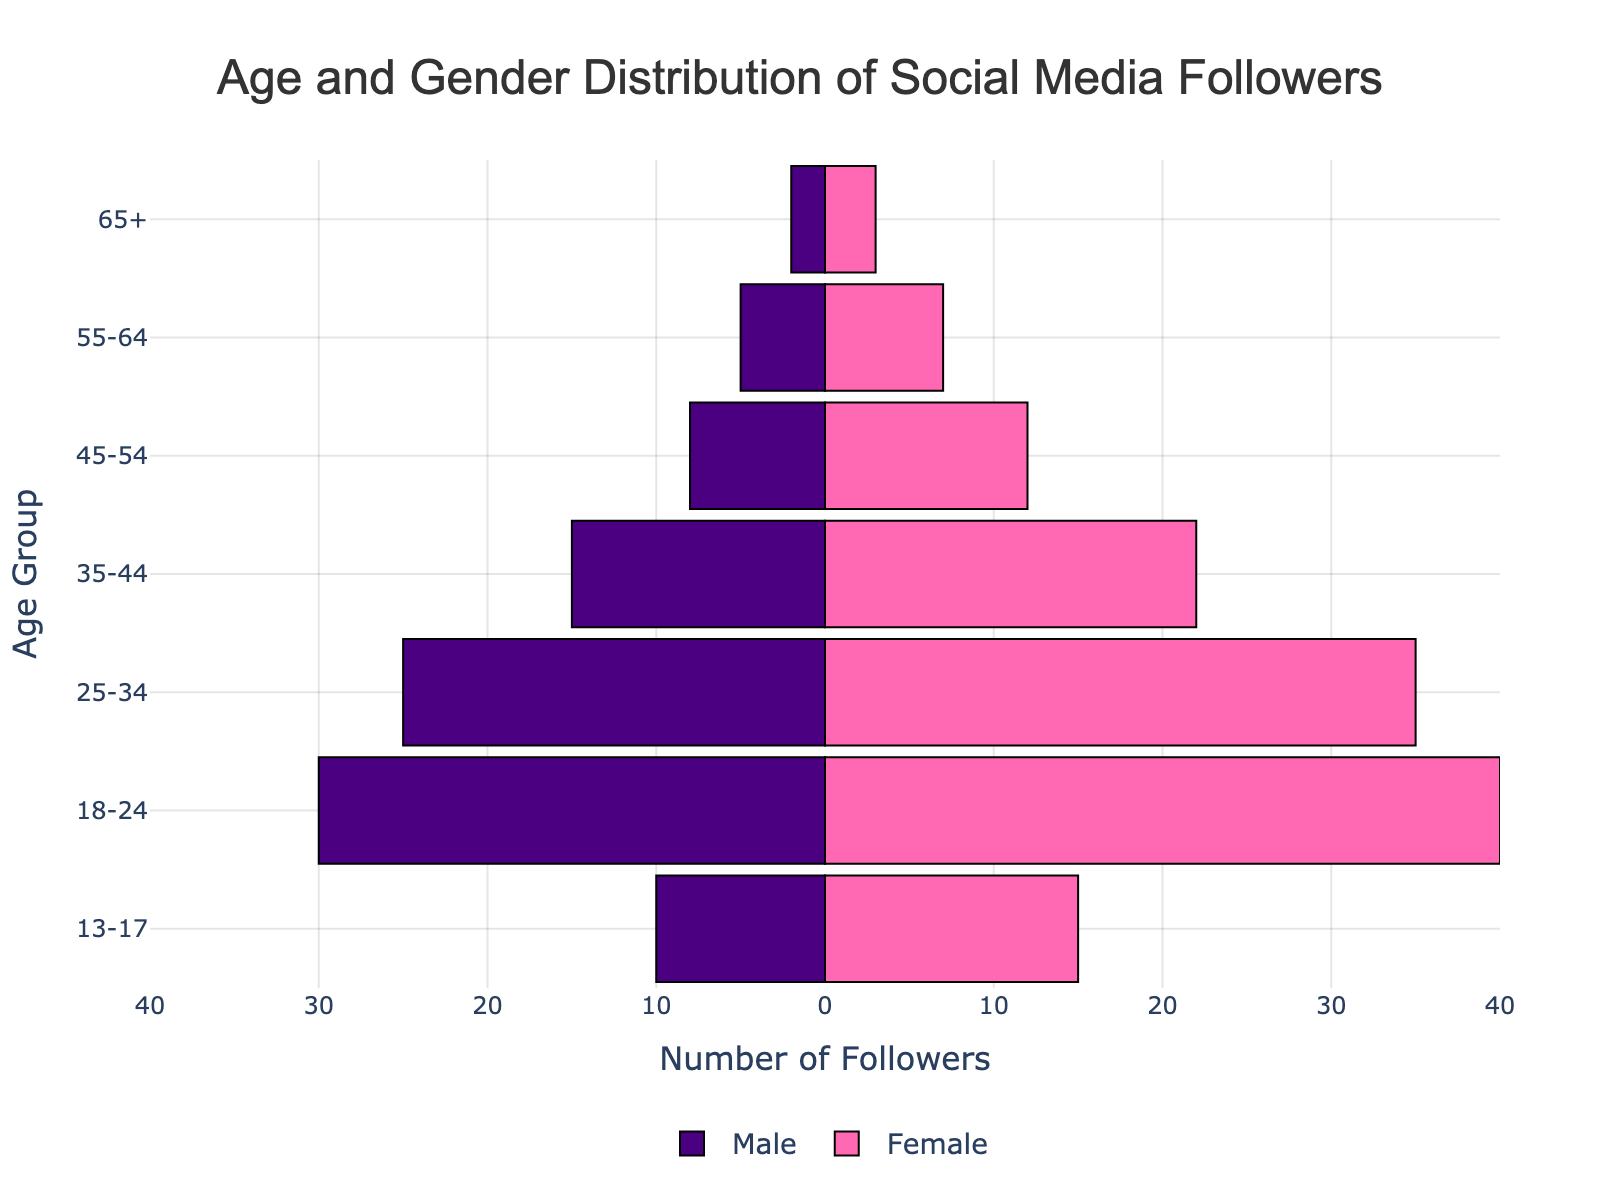What age group has the highest number of female followers? The population pyramid shows different age groups with bars indicating the number of followers. The largest bar on the right side (for females) is observed in the '18-24' age group.
Answer: 18-24 How many more female followers are there in the '25-34' age group compared to male followers in the same group? The number of female followers in the '25-34' age group is 35, and the number of male followers is 25. The difference is 35 - 25.
Answer: 10 Which age group has the least number of male followers? The population pyramid shows the smallest bar length on the left side (for males). The '65+' age group has the least bar indicating only 2 male followers.
Answer: 65+ In the '45-54' age group, are there more male or female followers? Comparing the length of the bars for male and female followers in the '45-54' group, the female bar is longer (12) compared to the male bar (8).
Answer: Female What is the total number of followers (both male and female) in the '35-44' age group? Add the number of male (15) and female (22) followers in the '35-44' age group. The total is 15 + 22.
Answer: 37 How does the number of male followers in the '13-17' age group compare to those in the '55-64' age group? The number of male followers in the '13-17' age group is 10, and in the '55-64' age group is 5. Thus, the '13-17' group has more male followers.
Answer: '13-17' more What's the total difference between male and female followers across all age groups? Sum up each category: Males (2+5+8+15+25+30+10=95) and Females (3+7+12+22+35+40+15=134), then subtract Male from Female (134-95).
Answer: 39 In which age group is the gender distribution most balanced? Compare the differences in the number of male and female followers for each age group and identify the smallest difference. The '55-64' age group has 5 males and 7 females, which means the difference is 2, the smallest among all groups.
Answer: 55-64 